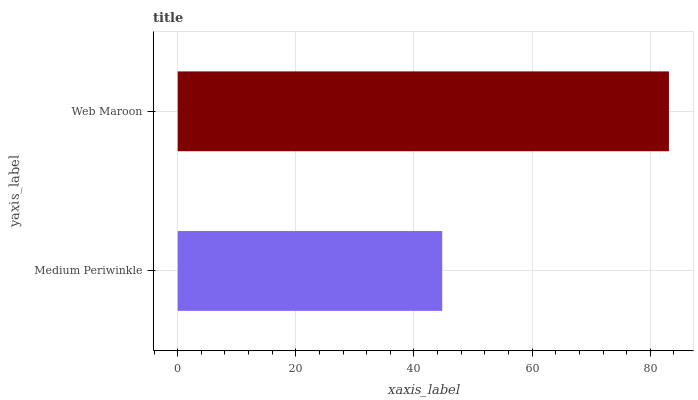Is Medium Periwinkle the minimum?
Answer yes or no. Yes. Is Web Maroon the maximum?
Answer yes or no. Yes. Is Web Maroon the minimum?
Answer yes or no. No. Is Web Maroon greater than Medium Periwinkle?
Answer yes or no. Yes. Is Medium Periwinkle less than Web Maroon?
Answer yes or no. Yes. Is Medium Periwinkle greater than Web Maroon?
Answer yes or no. No. Is Web Maroon less than Medium Periwinkle?
Answer yes or no. No. Is Web Maroon the high median?
Answer yes or no. Yes. Is Medium Periwinkle the low median?
Answer yes or no. Yes. Is Medium Periwinkle the high median?
Answer yes or no. No. Is Web Maroon the low median?
Answer yes or no. No. 